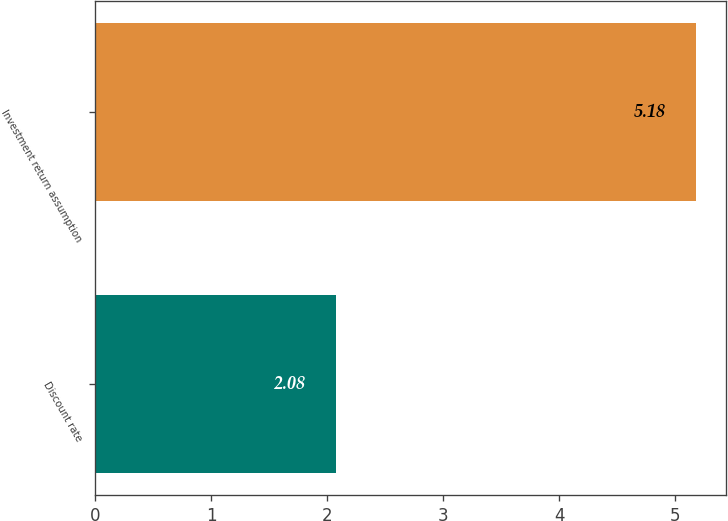Convert chart to OTSL. <chart><loc_0><loc_0><loc_500><loc_500><bar_chart><fcel>Discount rate<fcel>Investment return assumption<nl><fcel>2.08<fcel>5.18<nl></chart> 